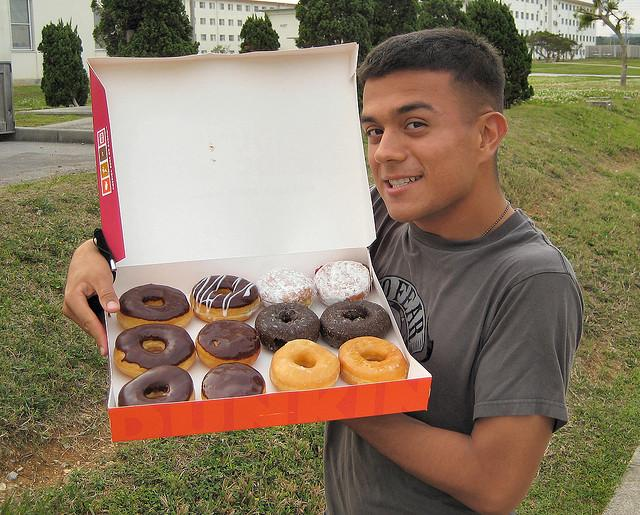What morning beverage is this company famous for? Please explain your reasoning. coffee. You eat donuts with coffee. 